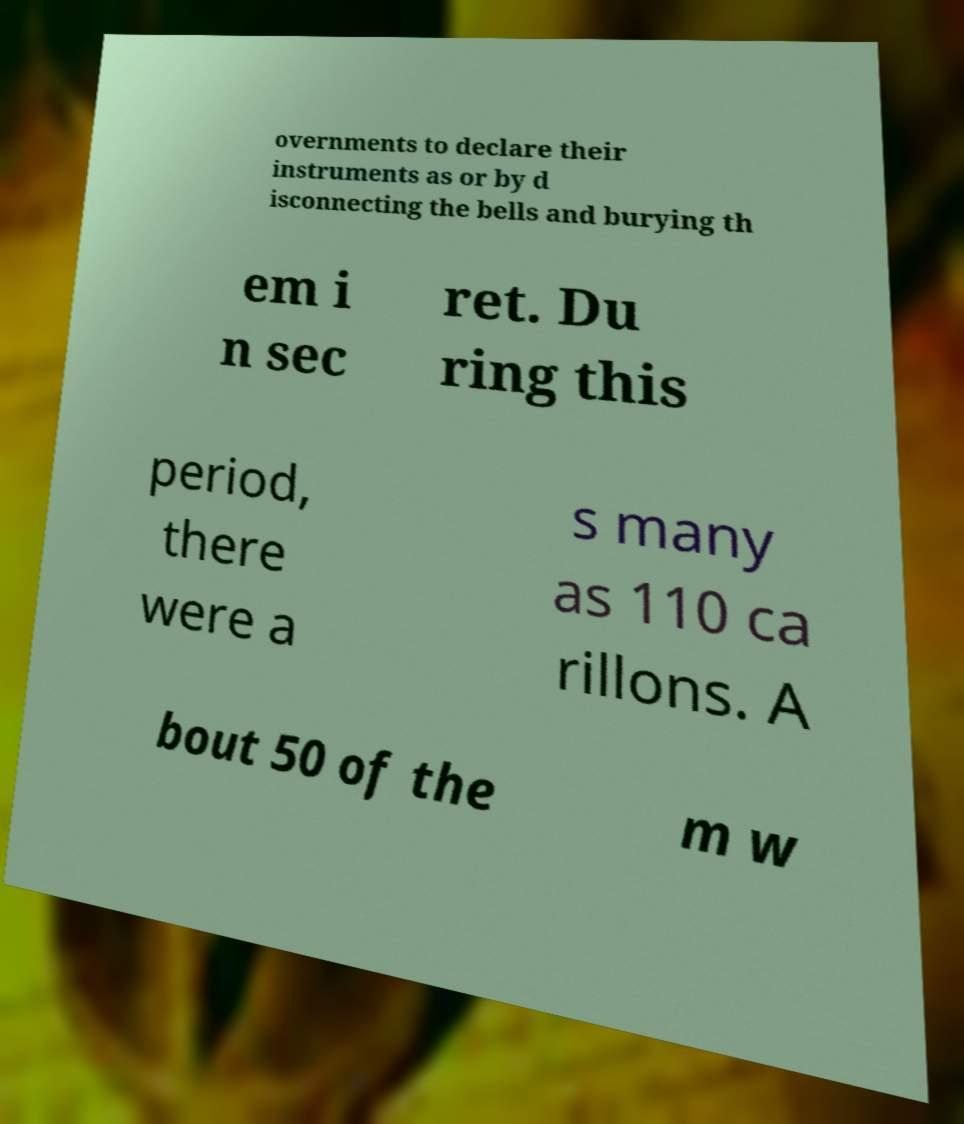Can you accurately transcribe the text from the provided image for me? overnments to declare their instruments as or by d isconnecting the bells and burying th em i n sec ret. Du ring this period, there were a s many as 110 ca rillons. A bout 50 of the m w 